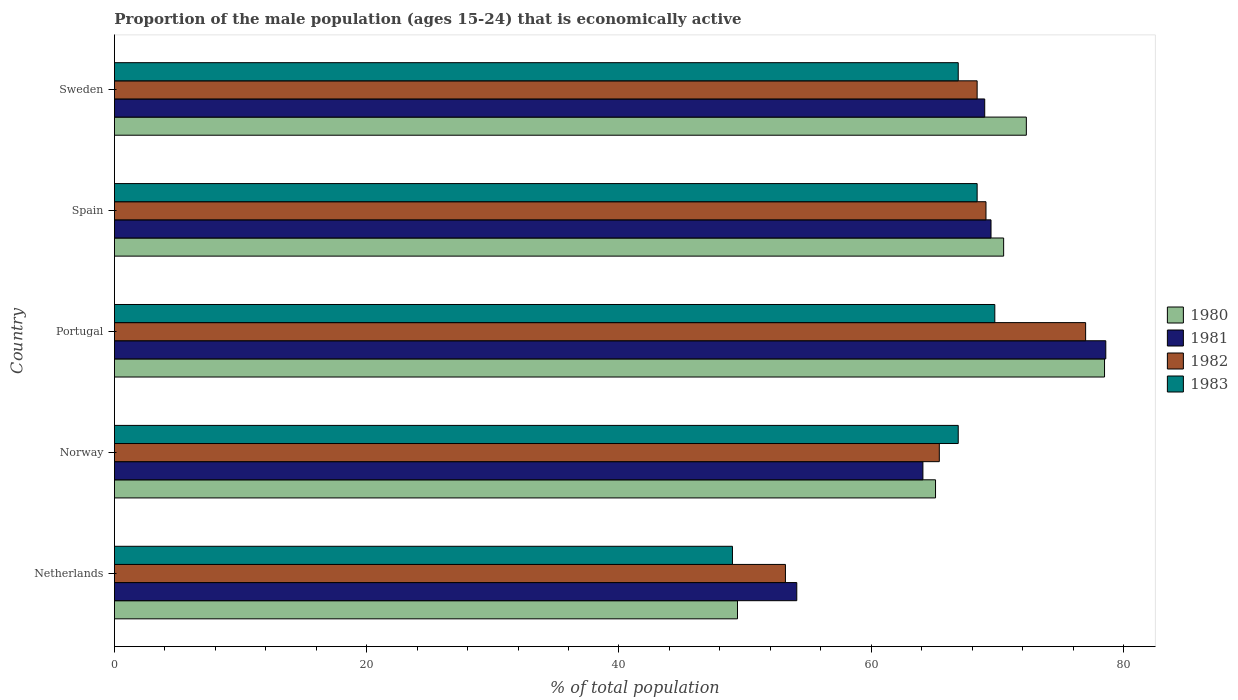How many different coloured bars are there?
Give a very brief answer. 4. How many groups of bars are there?
Provide a succinct answer. 5. Are the number of bars per tick equal to the number of legend labels?
Keep it short and to the point. Yes. How many bars are there on the 3rd tick from the top?
Offer a very short reply. 4. How many bars are there on the 5th tick from the bottom?
Provide a short and direct response. 4. What is the proportion of the male population that is economically active in 1982 in Portugal?
Provide a short and direct response. 77. Across all countries, what is the minimum proportion of the male population that is economically active in 1980?
Ensure brevity in your answer.  49.4. In which country was the proportion of the male population that is economically active in 1981 maximum?
Your answer should be very brief. Portugal. In which country was the proportion of the male population that is economically active in 1981 minimum?
Give a very brief answer. Netherlands. What is the total proportion of the male population that is economically active in 1981 in the graph?
Offer a terse response. 335.3. What is the difference between the proportion of the male population that is economically active in 1982 in Spain and that in Sweden?
Offer a very short reply. 0.7. What is the difference between the proportion of the male population that is economically active in 1980 in Portugal and the proportion of the male population that is economically active in 1983 in Norway?
Keep it short and to the point. 11.6. What is the average proportion of the male population that is economically active in 1980 per country?
Provide a short and direct response. 67.16. What is the difference between the proportion of the male population that is economically active in 1981 and proportion of the male population that is economically active in 1980 in Spain?
Offer a very short reply. -1. What is the ratio of the proportion of the male population that is economically active in 1980 in Norway to that in Spain?
Your answer should be compact. 0.92. Is the difference between the proportion of the male population that is economically active in 1981 in Netherlands and Portugal greater than the difference between the proportion of the male population that is economically active in 1980 in Netherlands and Portugal?
Ensure brevity in your answer.  Yes. What is the difference between the highest and the second highest proportion of the male population that is economically active in 1982?
Ensure brevity in your answer.  7.9. What is the difference between the highest and the lowest proportion of the male population that is economically active in 1983?
Your answer should be very brief. 20.8. In how many countries, is the proportion of the male population that is economically active in 1983 greater than the average proportion of the male population that is economically active in 1983 taken over all countries?
Provide a succinct answer. 4. Is it the case that in every country, the sum of the proportion of the male population that is economically active in 1983 and proportion of the male population that is economically active in 1981 is greater than the sum of proportion of the male population that is economically active in 1980 and proportion of the male population that is economically active in 1982?
Provide a short and direct response. No. What does the 2nd bar from the top in Portugal represents?
Your answer should be compact. 1982. What does the 3rd bar from the bottom in Norway represents?
Keep it short and to the point. 1982. Is it the case that in every country, the sum of the proportion of the male population that is economically active in 1983 and proportion of the male population that is economically active in 1981 is greater than the proportion of the male population that is economically active in 1982?
Your answer should be compact. Yes. Are all the bars in the graph horizontal?
Provide a succinct answer. Yes. How many countries are there in the graph?
Your response must be concise. 5. What is the difference between two consecutive major ticks on the X-axis?
Ensure brevity in your answer.  20. Does the graph contain any zero values?
Make the answer very short. No. Does the graph contain grids?
Make the answer very short. No. Where does the legend appear in the graph?
Keep it short and to the point. Center right. How are the legend labels stacked?
Provide a short and direct response. Vertical. What is the title of the graph?
Your answer should be compact. Proportion of the male population (ages 15-24) that is economically active. What is the label or title of the X-axis?
Offer a terse response. % of total population. What is the label or title of the Y-axis?
Keep it short and to the point. Country. What is the % of total population in 1980 in Netherlands?
Make the answer very short. 49.4. What is the % of total population of 1981 in Netherlands?
Give a very brief answer. 54.1. What is the % of total population of 1982 in Netherlands?
Provide a succinct answer. 53.2. What is the % of total population in 1980 in Norway?
Your answer should be very brief. 65.1. What is the % of total population of 1981 in Norway?
Your answer should be very brief. 64.1. What is the % of total population of 1982 in Norway?
Your response must be concise. 65.4. What is the % of total population of 1983 in Norway?
Give a very brief answer. 66.9. What is the % of total population of 1980 in Portugal?
Give a very brief answer. 78.5. What is the % of total population of 1981 in Portugal?
Ensure brevity in your answer.  78.6. What is the % of total population in 1982 in Portugal?
Offer a very short reply. 77. What is the % of total population of 1983 in Portugal?
Keep it short and to the point. 69.8. What is the % of total population in 1980 in Spain?
Offer a terse response. 70.5. What is the % of total population in 1981 in Spain?
Your response must be concise. 69.5. What is the % of total population in 1982 in Spain?
Your response must be concise. 69.1. What is the % of total population of 1983 in Spain?
Provide a short and direct response. 68.4. What is the % of total population in 1980 in Sweden?
Your answer should be compact. 72.3. What is the % of total population in 1981 in Sweden?
Ensure brevity in your answer.  69. What is the % of total population of 1982 in Sweden?
Ensure brevity in your answer.  68.4. What is the % of total population of 1983 in Sweden?
Your answer should be compact. 66.9. Across all countries, what is the maximum % of total population in 1980?
Provide a succinct answer. 78.5. Across all countries, what is the maximum % of total population in 1981?
Keep it short and to the point. 78.6. Across all countries, what is the maximum % of total population in 1983?
Provide a succinct answer. 69.8. Across all countries, what is the minimum % of total population of 1980?
Your response must be concise. 49.4. Across all countries, what is the minimum % of total population in 1981?
Offer a terse response. 54.1. Across all countries, what is the minimum % of total population in 1982?
Provide a short and direct response. 53.2. Across all countries, what is the minimum % of total population of 1983?
Keep it short and to the point. 49. What is the total % of total population of 1980 in the graph?
Give a very brief answer. 335.8. What is the total % of total population in 1981 in the graph?
Keep it short and to the point. 335.3. What is the total % of total population of 1982 in the graph?
Your response must be concise. 333.1. What is the total % of total population in 1983 in the graph?
Provide a short and direct response. 321. What is the difference between the % of total population of 1980 in Netherlands and that in Norway?
Your answer should be very brief. -15.7. What is the difference between the % of total population in 1983 in Netherlands and that in Norway?
Ensure brevity in your answer.  -17.9. What is the difference between the % of total population of 1980 in Netherlands and that in Portugal?
Your answer should be compact. -29.1. What is the difference between the % of total population in 1981 in Netherlands and that in Portugal?
Offer a very short reply. -24.5. What is the difference between the % of total population in 1982 in Netherlands and that in Portugal?
Provide a short and direct response. -23.8. What is the difference between the % of total population in 1983 in Netherlands and that in Portugal?
Your answer should be very brief. -20.8. What is the difference between the % of total population of 1980 in Netherlands and that in Spain?
Ensure brevity in your answer.  -21.1. What is the difference between the % of total population of 1981 in Netherlands and that in Spain?
Provide a succinct answer. -15.4. What is the difference between the % of total population of 1982 in Netherlands and that in Spain?
Provide a succinct answer. -15.9. What is the difference between the % of total population of 1983 in Netherlands and that in Spain?
Your answer should be compact. -19.4. What is the difference between the % of total population in 1980 in Netherlands and that in Sweden?
Your response must be concise. -22.9. What is the difference between the % of total population of 1981 in Netherlands and that in Sweden?
Offer a very short reply. -14.9. What is the difference between the % of total population in 1982 in Netherlands and that in Sweden?
Provide a short and direct response. -15.2. What is the difference between the % of total population of 1983 in Netherlands and that in Sweden?
Offer a very short reply. -17.9. What is the difference between the % of total population in 1980 in Norway and that in Portugal?
Provide a succinct answer. -13.4. What is the difference between the % of total population of 1982 in Norway and that in Portugal?
Provide a succinct answer. -11.6. What is the difference between the % of total population in 1983 in Norway and that in Portugal?
Offer a terse response. -2.9. What is the difference between the % of total population of 1983 in Norway and that in Spain?
Offer a terse response. -1.5. What is the difference between the % of total population of 1980 in Portugal and that in Spain?
Ensure brevity in your answer.  8. What is the difference between the % of total population in 1981 in Portugal and that in Spain?
Keep it short and to the point. 9.1. What is the difference between the % of total population in 1981 in Portugal and that in Sweden?
Offer a very short reply. 9.6. What is the difference between the % of total population in 1982 in Portugal and that in Sweden?
Offer a terse response. 8.6. What is the difference between the % of total population of 1982 in Spain and that in Sweden?
Your response must be concise. 0.7. What is the difference between the % of total population in 1983 in Spain and that in Sweden?
Give a very brief answer. 1.5. What is the difference between the % of total population of 1980 in Netherlands and the % of total population of 1981 in Norway?
Provide a short and direct response. -14.7. What is the difference between the % of total population in 1980 in Netherlands and the % of total population in 1983 in Norway?
Provide a succinct answer. -17.5. What is the difference between the % of total population in 1981 in Netherlands and the % of total population in 1982 in Norway?
Offer a terse response. -11.3. What is the difference between the % of total population in 1982 in Netherlands and the % of total population in 1983 in Norway?
Provide a short and direct response. -13.7. What is the difference between the % of total population of 1980 in Netherlands and the % of total population of 1981 in Portugal?
Make the answer very short. -29.2. What is the difference between the % of total population in 1980 in Netherlands and the % of total population in 1982 in Portugal?
Your answer should be very brief. -27.6. What is the difference between the % of total population of 1980 in Netherlands and the % of total population of 1983 in Portugal?
Your answer should be very brief. -20.4. What is the difference between the % of total population of 1981 in Netherlands and the % of total population of 1982 in Portugal?
Make the answer very short. -22.9. What is the difference between the % of total population in 1981 in Netherlands and the % of total population in 1983 in Portugal?
Your answer should be compact. -15.7. What is the difference between the % of total population of 1982 in Netherlands and the % of total population of 1983 in Portugal?
Offer a terse response. -16.6. What is the difference between the % of total population in 1980 in Netherlands and the % of total population in 1981 in Spain?
Make the answer very short. -20.1. What is the difference between the % of total population of 1980 in Netherlands and the % of total population of 1982 in Spain?
Provide a succinct answer. -19.7. What is the difference between the % of total population of 1980 in Netherlands and the % of total population of 1983 in Spain?
Your answer should be very brief. -19. What is the difference between the % of total population in 1981 in Netherlands and the % of total population in 1983 in Spain?
Your response must be concise. -14.3. What is the difference between the % of total population of 1982 in Netherlands and the % of total population of 1983 in Spain?
Provide a short and direct response. -15.2. What is the difference between the % of total population in 1980 in Netherlands and the % of total population in 1981 in Sweden?
Make the answer very short. -19.6. What is the difference between the % of total population of 1980 in Netherlands and the % of total population of 1982 in Sweden?
Provide a short and direct response. -19. What is the difference between the % of total population of 1980 in Netherlands and the % of total population of 1983 in Sweden?
Give a very brief answer. -17.5. What is the difference between the % of total population of 1981 in Netherlands and the % of total population of 1982 in Sweden?
Ensure brevity in your answer.  -14.3. What is the difference between the % of total population in 1981 in Netherlands and the % of total population in 1983 in Sweden?
Ensure brevity in your answer.  -12.8. What is the difference between the % of total population of 1982 in Netherlands and the % of total population of 1983 in Sweden?
Provide a succinct answer. -13.7. What is the difference between the % of total population of 1980 in Norway and the % of total population of 1981 in Portugal?
Offer a terse response. -13.5. What is the difference between the % of total population in 1981 in Norway and the % of total population in 1983 in Portugal?
Ensure brevity in your answer.  -5.7. What is the difference between the % of total population of 1982 in Norway and the % of total population of 1983 in Portugal?
Provide a succinct answer. -4.4. What is the difference between the % of total population of 1982 in Norway and the % of total population of 1983 in Spain?
Offer a terse response. -3. What is the difference between the % of total population in 1980 in Norway and the % of total population in 1981 in Sweden?
Your answer should be very brief. -3.9. What is the difference between the % of total population of 1981 in Norway and the % of total population of 1983 in Sweden?
Your answer should be very brief. -2.8. What is the difference between the % of total population of 1980 in Portugal and the % of total population of 1981 in Spain?
Keep it short and to the point. 9. What is the difference between the % of total population in 1980 in Portugal and the % of total population in 1982 in Spain?
Offer a very short reply. 9.4. What is the difference between the % of total population of 1980 in Portugal and the % of total population of 1983 in Spain?
Ensure brevity in your answer.  10.1. What is the difference between the % of total population in 1981 in Portugal and the % of total population in 1982 in Spain?
Your answer should be compact. 9.5. What is the difference between the % of total population in 1981 in Portugal and the % of total population in 1983 in Spain?
Offer a very short reply. 10.2. What is the difference between the % of total population of 1982 in Portugal and the % of total population of 1983 in Spain?
Give a very brief answer. 8.6. What is the difference between the % of total population of 1980 in Portugal and the % of total population of 1981 in Sweden?
Provide a short and direct response. 9.5. What is the difference between the % of total population of 1980 in Portugal and the % of total population of 1983 in Sweden?
Keep it short and to the point. 11.6. What is the difference between the % of total population in 1981 in Portugal and the % of total population in 1982 in Sweden?
Provide a short and direct response. 10.2. What is the difference between the % of total population in 1981 in Portugal and the % of total population in 1983 in Sweden?
Offer a very short reply. 11.7. What is the difference between the % of total population in 1980 in Spain and the % of total population in 1983 in Sweden?
Make the answer very short. 3.6. What is the difference between the % of total population in 1981 in Spain and the % of total population in 1983 in Sweden?
Offer a terse response. 2.6. What is the difference between the % of total population of 1982 in Spain and the % of total population of 1983 in Sweden?
Give a very brief answer. 2.2. What is the average % of total population in 1980 per country?
Provide a succinct answer. 67.16. What is the average % of total population of 1981 per country?
Provide a succinct answer. 67.06. What is the average % of total population in 1982 per country?
Give a very brief answer. 66.62. What is the average % of total population of 1983 per country?
Ensure brevity in your answer.  64.2. What is the difference between the % of total population in 1981 and % of total population in 1982 in Netherlands?
Offer a terse response. 0.9. What is the difference between the % of total population in 1980 and % of total population in 1981 in Norway?
Offer a terse response. 1. What is the difference between the % of total population of 1980 and % of total population of 1983 in Norway?
Your answer should be very brief. -1.8. What is the difference between the % of total population of 1981 and % of total population of 1982 in Norway?
Ensure brevity in your answer.  -1.3. What is the difference between the % of total population of 1981 and % of total population of 1983 in Norway?
Your answer should be very brief. -2.8. What is the difference between the % of total population of 1980 and % of total population of 1981 in Portugal?
Provide a succinct answer. -0.1. What is the difference between the % of total population of 1980 and % of total population of 1983 in Portugal?
Offer a terse response. 8.7. What is the difference between the % of total population of 1981 and % of total population of 1982 in Portugal?
Ensure brevity in your answer.  1.6. What is the difference between the % of total population in 1980 and % of total population in 1981 in Spain?
Your answer should be very brief. 1. What is the difference between the % of total population of 1980 and % of total population of 1983 in Spain?
Your response must be concise. 2.1. What is the difference between the % of total population in 1981 and % of total population in 1983 in Spain?
Provide a succinct answer. 1.1. What is the difference between the % of total population in 1982 and % of total population in 1983 in Spain?
Offer a very short reply. 0.7. What is the difference between the % of total population in 1980 and % of total population in 1983 in Sweden?
Provide a short and direct response. 5.4. What is the difference between the % of total population in 1981 and % of total population in 1983 in Sweden?
Offer a terse response. 2.1. What is the difference between the % of total population of 1982 and % of total population of 1983 in Sweden?
Ensure brevity in your answer.  1.5. What is the ratio of the % of total population in 1980 in Netherlands to that in Norway?
Provide a short and direct response. 0.76. What is the ratio of the % of total population in 1981 in Netherlands to that in Norway?
Keep it short and to the point. 0.84. What is the ratio of the % of total population of 1982 in Netherlands to that in Norway?
Give a very brief answer. 0.81. What is the ratio of the % of total population of 1983 in Netherlands to that in Norway?
Keep it short and to the point. 0.73. What is the ratio of the % of total population of 1980 in Netherlands to that in Portugal?
Give a very brief answer. 0.63. What is the ratio of the % of total population in 1981 in Netherlands to that in Portugal?
Provide a short and direct response. 0.69. What is the ratio of the % of total population in 1982 in Netherlands to that in Portugal?
Your answer should be very brief. 0.69. What is the ratio of the % of total population in 1983 in Netherlands to that in Portugal?
Keep it short and to the point. 0.7. What is the ratio of the % of total population in 1980 in Netherlands to that in Spain?
Offer a terse response. 0.7. What is the ratio of the % of total population of 1981 in Netherlands to that in Spain?
Offer a terse response. 0.78. What is the ratio of the % of total population in 1982 in Netherlands to that in Spain?
Make the answer very short. 0.77. What is the ratio of the % of total population of 1983 in Netherlands to that in Spain?
Offer a terse response. 0.72. What is the ratio of the % of total population in 1980 in Netherlands to that in Sweden?
Keep it short and to the point. 0.68. What is the ratio of the % of total population of 1981 in Netherlands to that in Sweden?
Provide a succinct answer. 0.78. What is the ratio of the % of total population of 1983 in Netherlands to that in Sweden?
Offer a terse response. 0.73. What is the ratio of the % of total population in 1980 in Norway to that in Portugal?
Your answer should be very brief. 0.83. What is the ratio of the % of total population of 1981 in Norway to that in Portugal?
Your answer should be very brief. 0.82. What is the ratio of the % of total population of 1982 in Norway to that in Portugal?
Offer a terse response. 0.85. What is the ratio of the % of total population of 1983 in Norway to that in Portugal?
Your answer should be compact. 0.96. What is the ratio of the % of total population in 1980 in Norway to that in Spain?
Make the answer very short. 0.92. What is the ratio of the % of total population of 1981 in Norway to that in Spain?
Provide a succinct answer. 0.92. What is the ratio of the % of total population in 1982 in Norway to that in Spain?
Your answer should be very brief. 0.95. What is the ratio of the % of total population in 1983 in Norway to that in Spain?
Give a very brief answer. 0.98. What is the ratio of the % of total population of 1980 in Norway to that in Sweden?
Keep it short and to the point. 0.9. What is the ratio of the % of total population in 1981 in Norway to that in Sweden?
Offer a very short reply. 0.93. What is the ratio of the % of total population of 1982 in Norway to that in Sweden?
Your answer should be very brief. 0.96. What is the ratio of the % of total population of 1980 in Portugal to that in Spain?
Your response must be concise. 1.11. What is the ratio of the % of total population of 1981 in Portugal to that in Spain?
Provide a short and direct response. 1.13. What is the ratio of the % of total population in 1982 in Portugal to that in Spain?
Keep it short and to the point. 1.11. What is the ratio of the % of total population of 1983 in Portugal to that in Spain?
Ensure brevity in your answer.  1.02. What is the ratio of the % of total population in 1980 in Portugal to that in Sweden?
Your response must be concise. 1.09. What is the ratio of the % of total population of 1981 in Portugal to that in Sweden?
Provide a short and direct response. 1.14. What is the ratio of the % of total population of 1982 in Portugal to that in Sweden?
Make the answer very short. 1.13. What is the ratio of the % of total population of 1983 in Portugal to that in Sweden?
Ensure brevity in your answer.  1.04. What is the ratio of the % of total population in 1980 in Spain to that in Sweden?
Keep it short and to the point. 0.98. What is the ratio of the % of total population of 1981 in Spain to that in Sweden?
Offer a very short reply. 1.01. What is the ratio of the % of total population of 1982 in Spain to that in Sweden?
Ensure brevity in your answer.  1.01. What is the ratio of the % of total population of 1983 in Spain to that in Sweden?
Provide a short and direct response. 1.02. What is the difference between the highest and the second highest % of total population in 1980?
Your answer should be compact. 6.2. What is the difference between the highest and the lowest % of total population of 1980?
Your answer should be compact. 29.1. What is the difference between the highest and the lowest % of total population of 1981?
Give a very brief answer. 24.5. What is the difference between the highest and the lowest % of total population of 1982?
Provide a succinct answer. 23.8. What is the difference between the highest and the lowest % of total population in 1983?
Give a very brief answer. 20.8. 